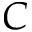<formula> <loc_0><loc_0><loc_500><loc_500>C</formula> 